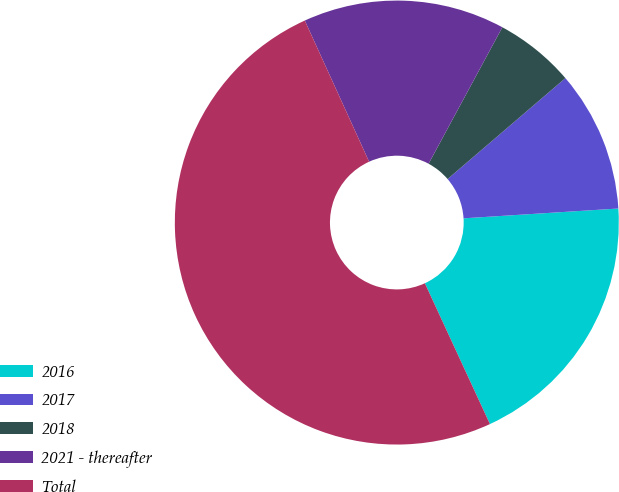Convert chart to OTSL. <chart><loc_0><loc_0><loc_500><loc_500><pie_chart><fcel>2016<fcel>2017<fcel>2018<fcel>2021 - thereafter<fcel>Total<nl><fcel>19.12%<fcel>10.27%<fcel>5.84%<fcel>14.69%<fcel>50.09%<nl></chart> 